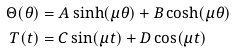<formula> <loc_0><loc_0><loc_500><loc_500>\Theta ( \theta ) & = A \sinh ( \mu \theta ) + B \cosh ( \mu \theta ) \\ T ( t ) & = C \sin ( \mu t ) + D \cos ( \mu t ) \\</formula> 